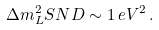Convert formula to latex. <formula><loc_0><loc_0><loc_500><loc_500>\Delta { m } ^ { 2 } _ { L } S N D \sim 1 \, e V ^ { 2 } \, .</formula> 